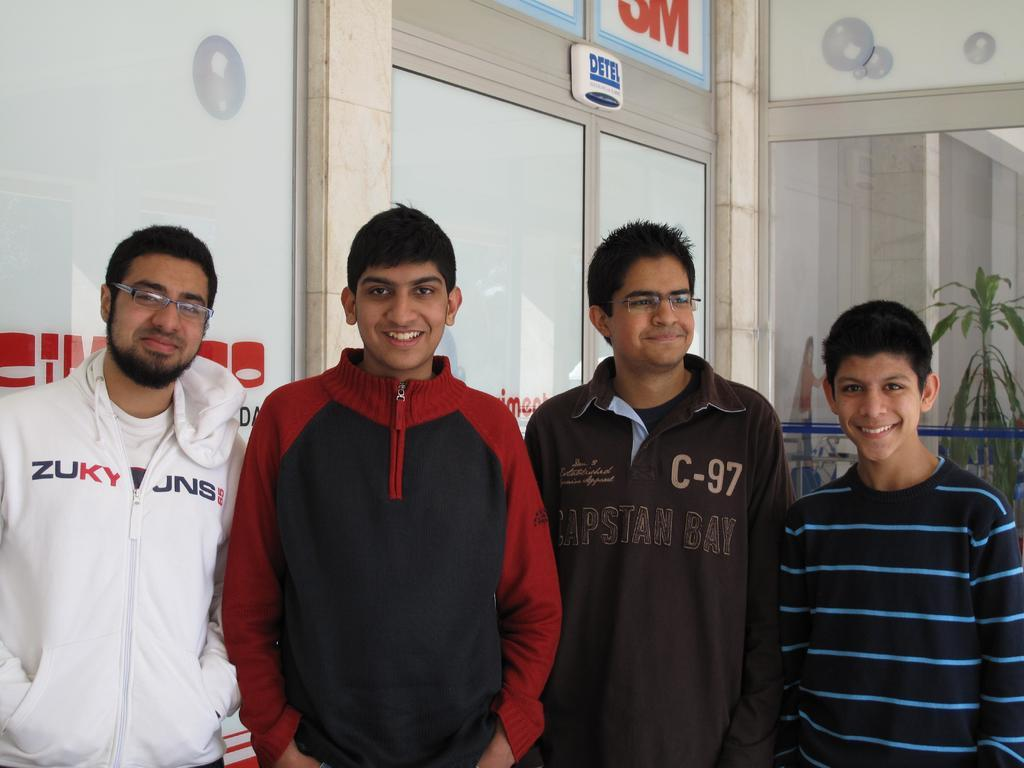<image>
Describe the image concisely. Four men stand together near a 3M store. 